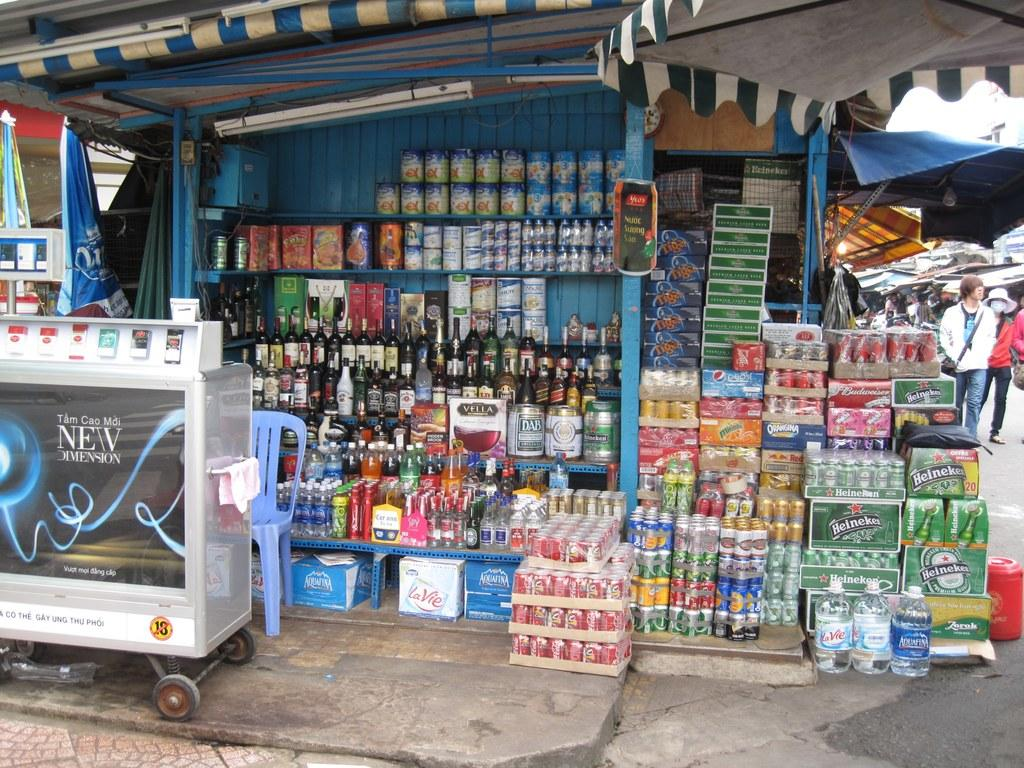<image>
Render a clear and concise summary of the photo. A liquor kiosk with boxes of Heineken and Pepsi. 